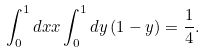Convert formula to latex. <formula><loc_0><loc_0><loc_500><loc_500>\int ^ { 1 } _ { 0 } d x x \int ^ { 1 } _ { 0 } d y \, ( 1 - y ) = \frac { 1 } { 4 } .</formula> 